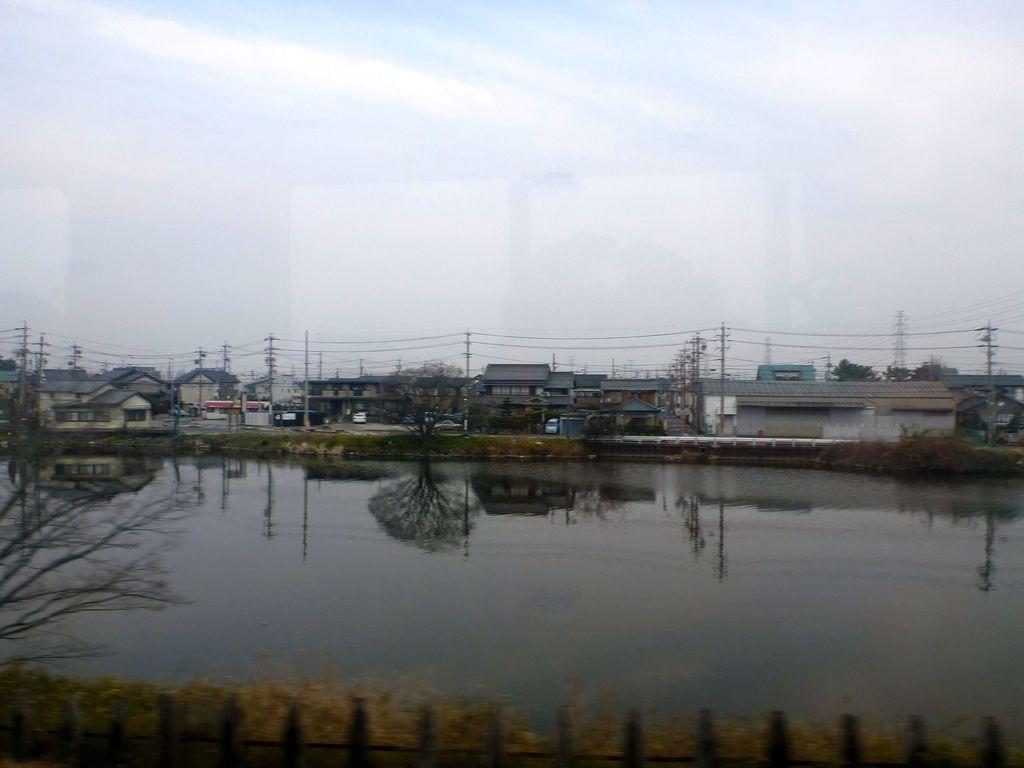Please provide a concise description of this image. In this image there is the sky towards the top of the image, there are clouds in the sky, there are houses, there are poles, there are wires, there is water, there are plants towards the bottom of the image, there is a tree towards the left of the image, there is a wooden fence towards the bottom of the image. 